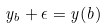Convert formula to latex. <formula><loc_0><loc_0><loc_500><loc_500>y _ { b } + \epsilon = y ( b )</formula> 